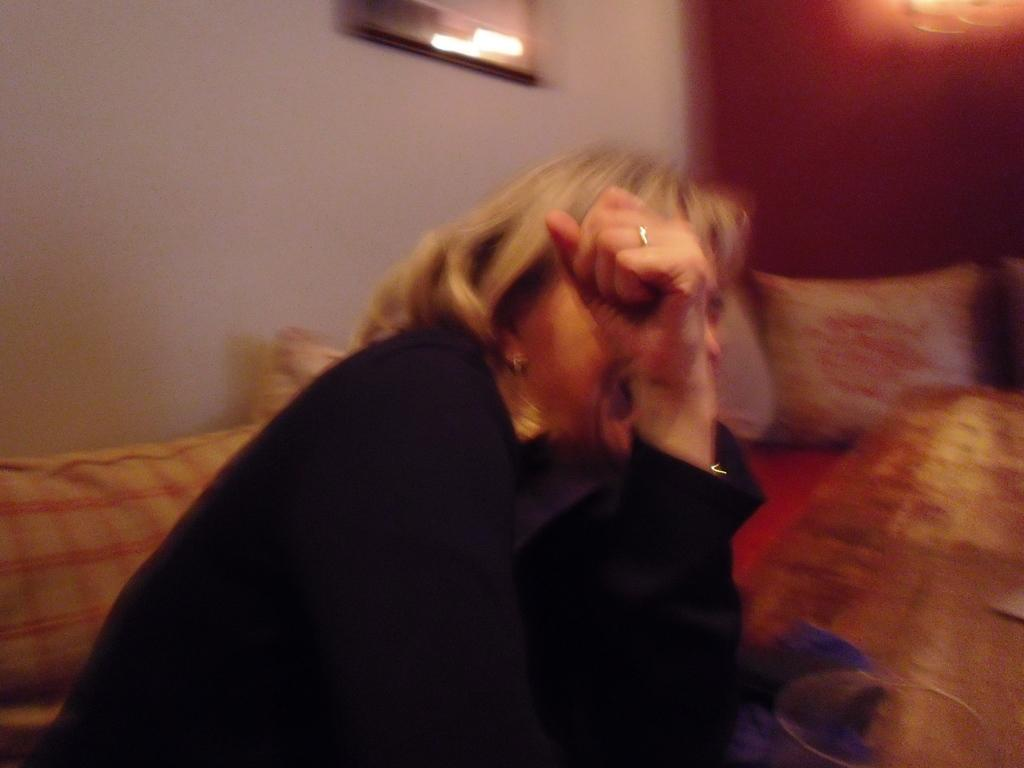Who or what is in the image? There is a person in the image. What is the person wearing? The person is wearing a black dress. Where is the person sitting? The person is sitting on a bed. What else can be seen on the bed? There are pillows visible in the image. How is the image framed? The frame is attached to the wall. What type of sound can be heard coming from the person's boot in the image? There is no boot present in the image, and therefore no sound can be heard coming from it. 